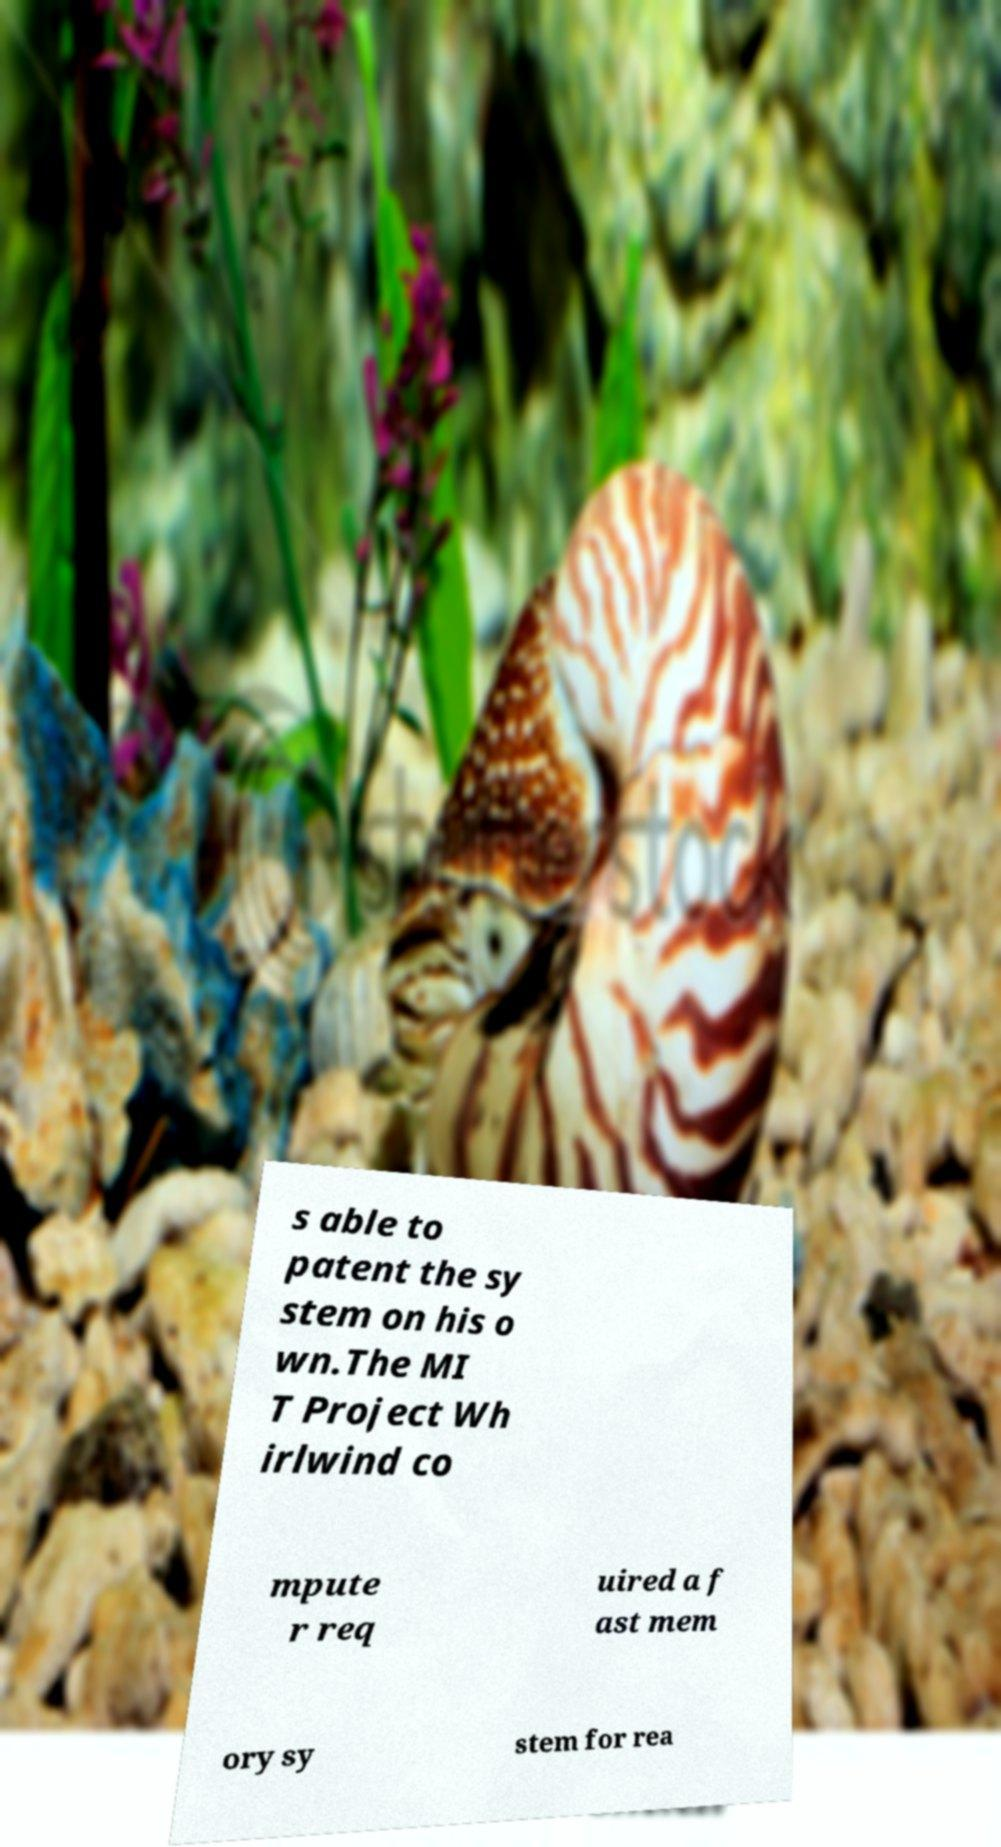Can you read and provide the text displayed in the image?This photo seems to have some interesting text. Can you extract and type it out for me? s able to patent the sy stem on his o wn.The MI T Project Wh irlwind co mpute r req uired a f ast mem ory sy stem for rea 